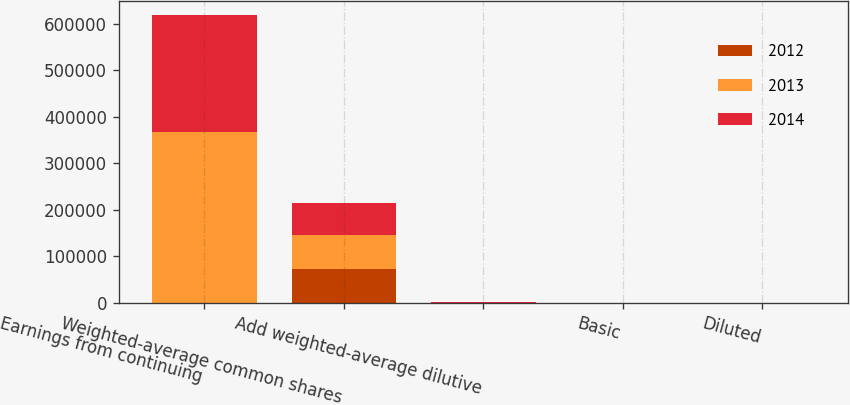Convert chart to OTSL. <chart><loc_0><loc_0><loc_500><loc_500><stacked_bar_chart><ecel><fcel>Earnings from continuing<fcel>Weighted-average common shares<fcel>Add weighted-average dilutive<fcel>Basic<fcel>Diluted<nl><fcel>2012<fcel>528<fcel>73363<fcel>526<fcel>7.3<fcel>7.25<nl><fcel>2013<fcel>366681<fcel>72301<fcel>528<fcel>5.11<fcel>5.07<nl><fcel>2014<fcel>250258<fcel>69306<fcel>318<fcel>3.63<fcel>3.61<nl></chart> 